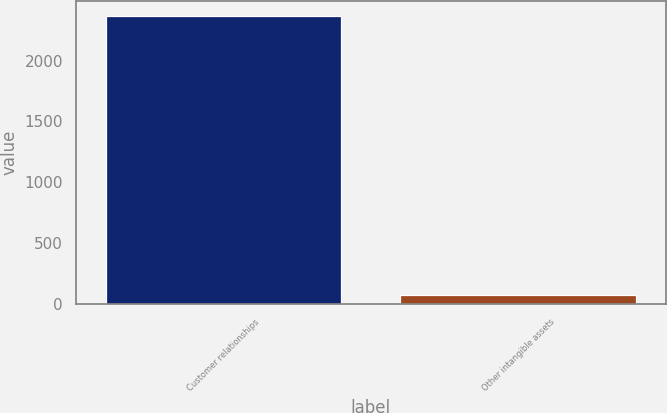<chart> <loc_0><loc_0><loc_500><loc_500><bar_chart><fcel>Customer relationships<fcel>Other intangible assets<nl><fcel>2368<fcel>79<nl></chart> 